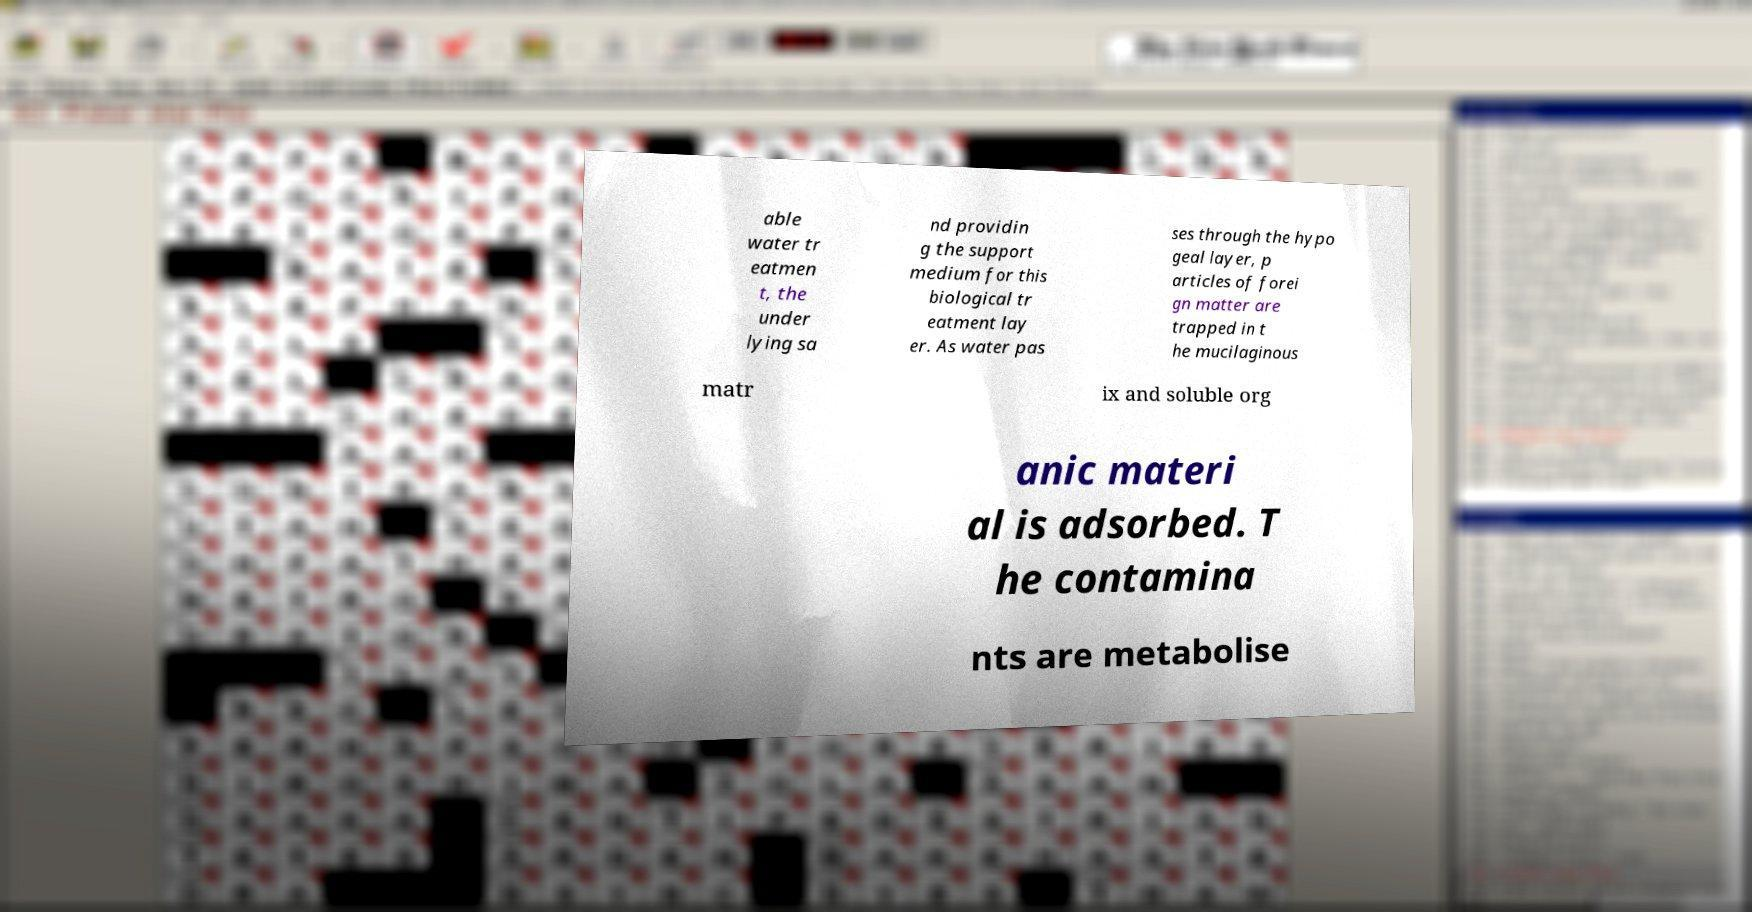For documentation purposes, I need the text within this image transcribed. Could you provide that? able water tr eatmen t, the under lying sa nd providin g the support medium for this biological tr eatment lay er. As water pas ses through the hypo geal layer, p articles of forei gn matter are trapped in t he mucilaginous matr ix and soluble org anic materi al is adsorbed. T he contamina nts are metabolise 